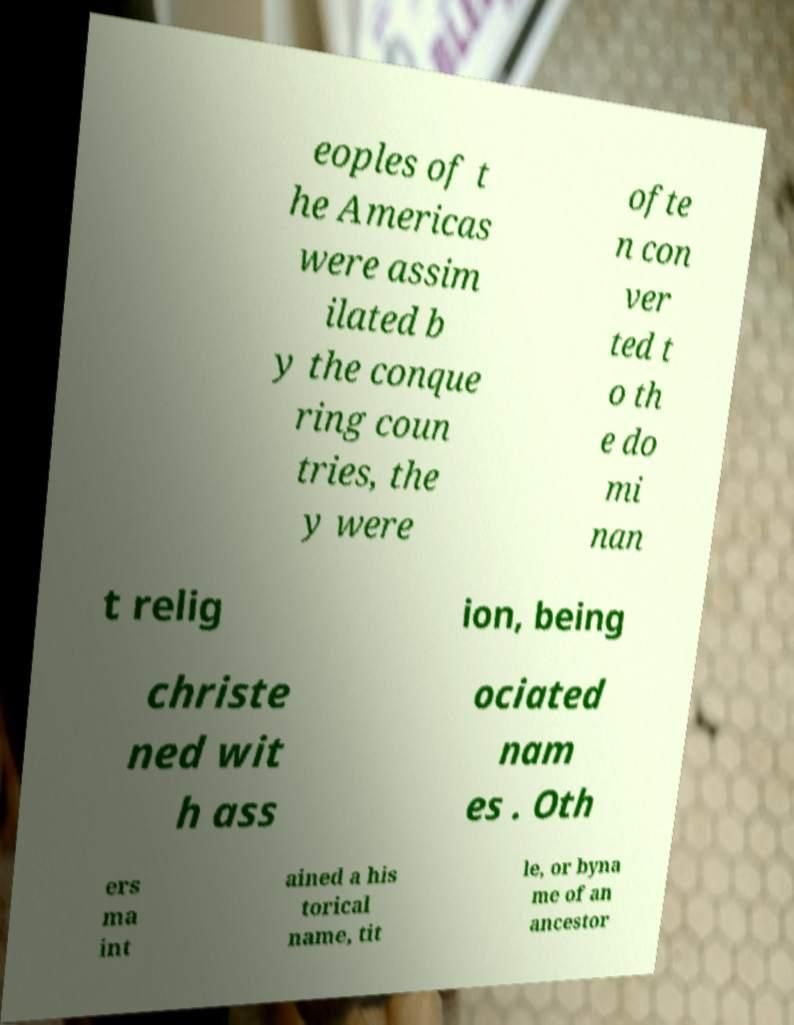Please identify and transcribe the text found in this image. eoples of t he Americas were assim ilated b y the conque ring coun tries, the y were ofte n con ver ted t o th e do mi nan t relig ion, being christe ned wit h ass ociated nam es . Oth ers ma int ained a his torical name, tit le, or byna me of an ancestor 